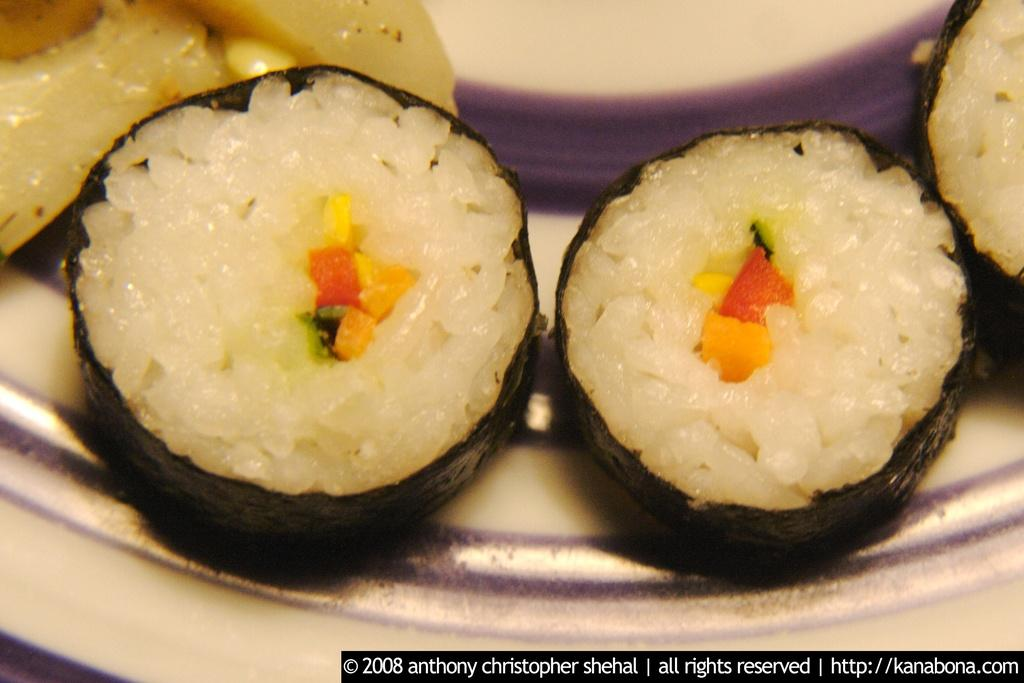What object can be seen in the image that might be used for serving or presenting food? There is a plate in the image that can be used for serving or presenting food. What is on the plate in the image? There is food on the plate in the image. What type of plantation can be seen in the background of the image? There is no plantation present in the image; it only features a plate with food on it. What type of fork is being used to eat the food in the image? There is no fork visible in the image; only a plate with food is present. 